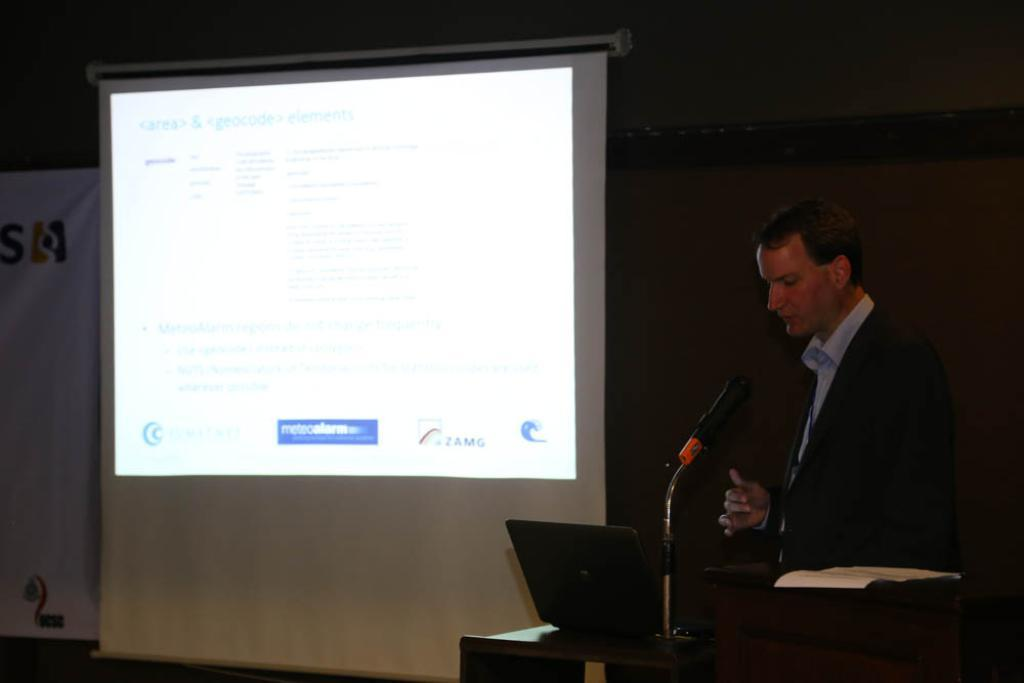What is the person in the image doing? The person is standing and speaking in front of a microphone. What might be the purpose of the microphone in the image? The microphone is likely being used to amplify the person's voice, suggesting they may be giving a speech or presentation. What can be seen in the background of the image? There is a projected image visible in the background. What type of powder is being used to create the projected image in the background? There is no powder present in the image, and the projected image is not created using any powder. 